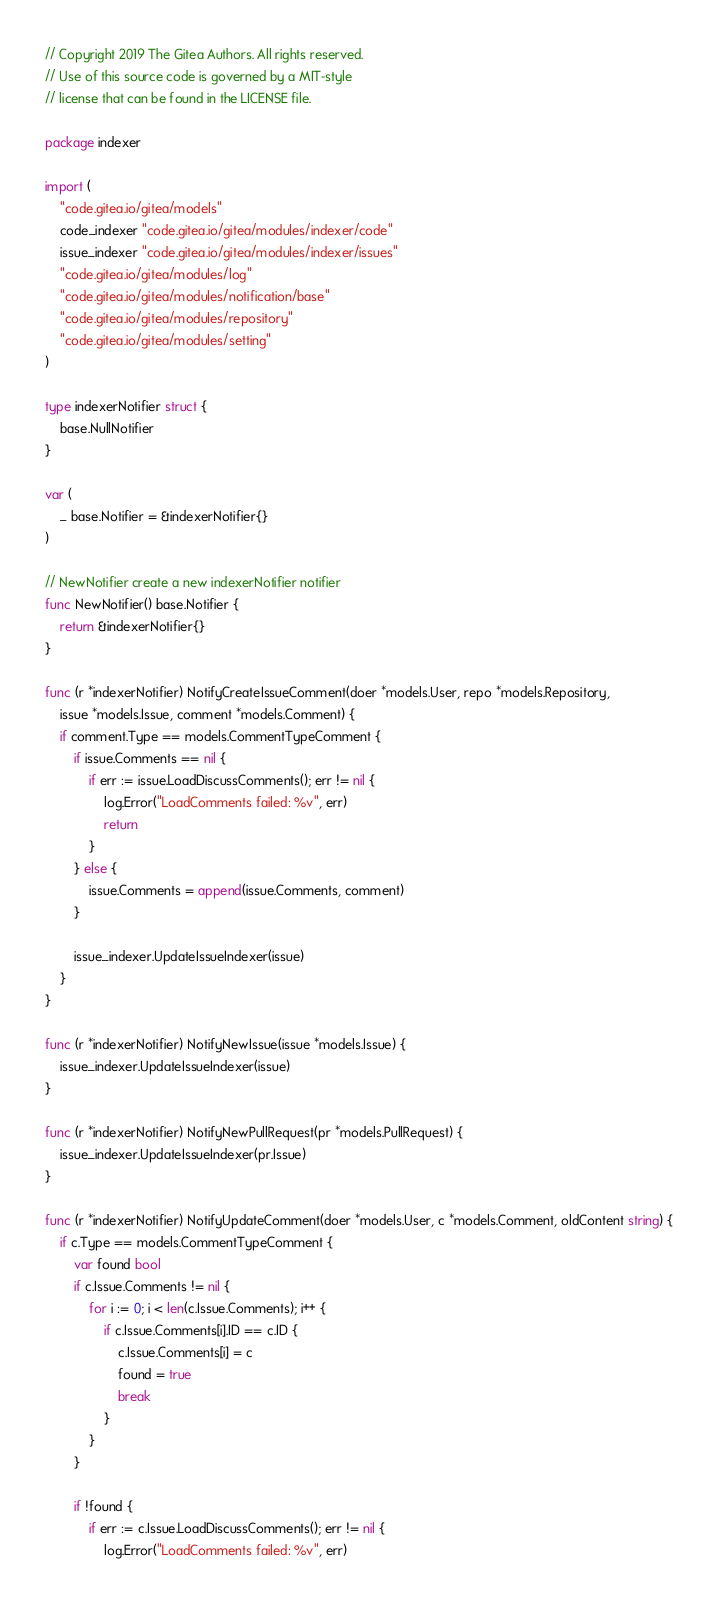<code> <loc_0><loc_0><loc_500><loc_500><_Go_>// Copyright 2019 The Gitea Authors. All rights reserved.
// Use of this source code is governed by a MIT-style
// license that can be found in the LICENSE file.

package indexer

import (
	"code.gitea.io/gitea/models"
	code_indexer "code.gitea.io/gitea/modules/indexer/code"
	issue_indexer "code.gitea.io/gitea/modules/indexer/issues"
	"code.gitea.io/gitea/modules/log"
	"code.gitea.io/gitea/modules/notification/base"
	"code.gitea.io/gitea/modules/repository"
	"code.gitea.io/gitea/modules/setting"
)

type indexerNotifier struct {
	base.NullNotifier
}

var (
	_ base.Notifier = &indexerNotifier{}
)

// NewNotifier create a new indexerNotifier notifier
func NewNotifier() base.Notifier {
	return &indexerNotifier{}
}

func (r *indexerNotifier) NotifyCreateIssueComment(doer *models.User, repo *models.Repository,
	issue *models.Issue, comment *models.Comment) {
	if comment.Type == models.CommentTypeComment {
		if issue.Comments == nil {
			if err := issue.LoadDiscussComments(); err != nil {
				log.Error("LoadComments failed: %v", err)
				return
			}
		} else {
			issue.Comments = append(issue.Comments, comment)
		}

		issue_indexer.UpdateIssueIndexer(issue)
	}
}

func (r *indexerNotifier) NotifyNewIssue(issue *models.Issue) {
	issue_indexer.UpdateIssueIndexer(issue)
}

func (r *indexerNotifier) NotifyNewPullRequest(pr *models.PullRequest) {
	issue_indexer.UpdateIssueIndexer(pr.Issue)
}

func (r *indexerNotifier) NotifyUpdateComment(doer *models.User, c *models.Comment, oldContent string) {
	if c.Type == models.CommentTypeComment {
		var found bool
		if c.Issue.Comments != nil {
			for i := 0; i < len(c.Issue.Comments); i++ {
				if c.Issue.Comments[i].ID == c.ID {
					c.Issue.Comments[i] = c
					found = true
					break
				}
			}
		}

		if !found {
			if err := c.Issue.LoadDiscussComments(); err != nil {
				log.Error("LoadComments failed: %v", err)</code> 